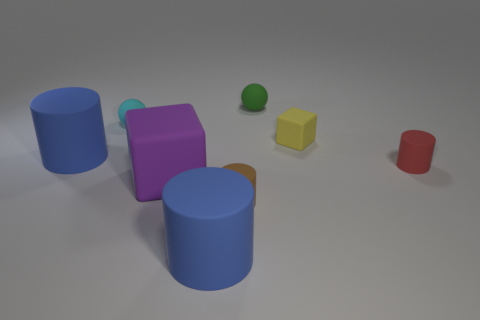Add 1 purple metallic objects. How many objects exist? 9 Subtract all brown cylinders. How many cylinders are left? 3 Subtract all small red rubber cylinders. How many cylinders are left? 3 Add 7 large purple things. How many large purple things exist? 8 Subtract 0 green cubes. How many objects are left? 8 Subtract 2 cylinders. How many cylinders are left? 2 Subtract all red cylinders. Subtract all purple cubes. How many cylinders are left? 3 Subtract all red blocks. How many cyan balls are left? 1 Subtract all big red metallic blocks. Subtract all rubber cylinders. How many objects are left? 4 Add 5 large matte cubes. How many large matte cubes are left? 6 